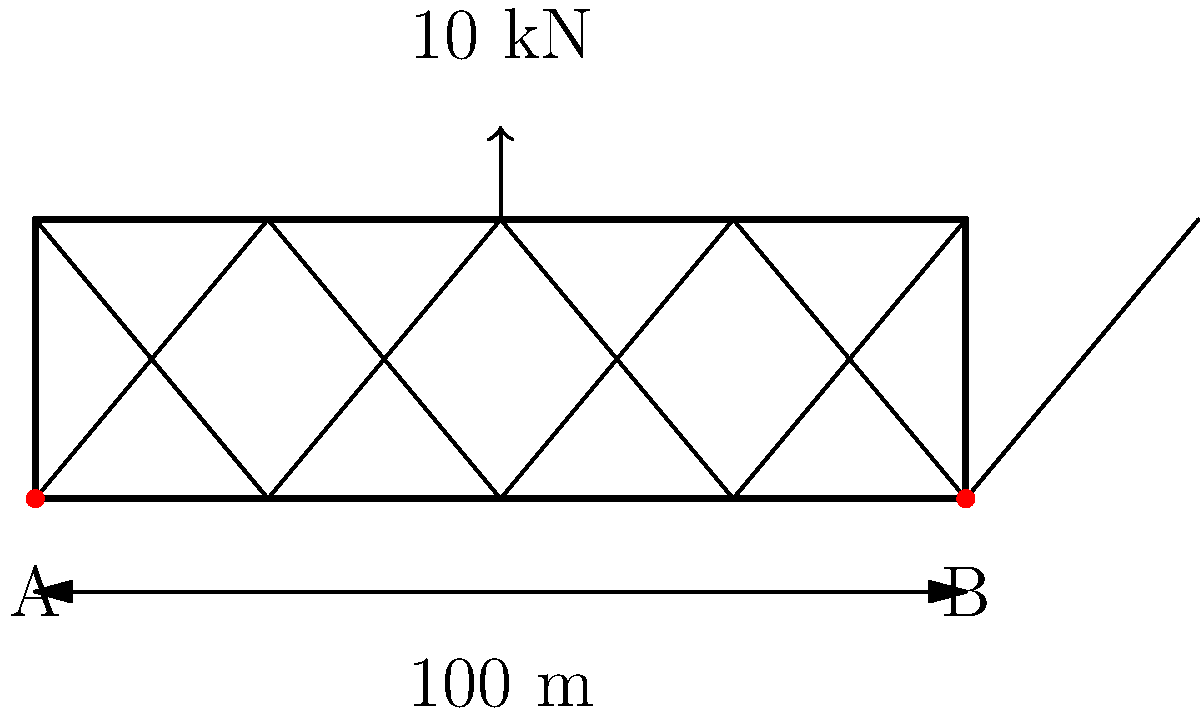In this absolutely groundbreaking and totally original truss bridge design (because who needs actual innovation when we can just recycle old ideas?), a 10 kN load is applied at the center of the top chord. Assuming this masterpiece of engineering is simply supported at A and B, what's the reaction force at support B? Don't strain yourself too much; it's not like understanding this will make you the next Banksy of bridge design. Alright, let's break this down for those who might be more interested in the structural integrity of their NFT collection than actual bridges:

1) First, we need to realize this is a simple statics problem. The bridge is in equilibrium, so the sum of all forces and moments must be zero.

2) Let's define our coordinate system:
   - Positive vertical forces point upward
   - Positive moments are counterclockwise

3) Let $R_A$ and $R_B$ be the reaction forces at supports A and B, respectively.

4) Sum of vertical forces must be zero:
   $$R_A + R_B - 10 \text{ kN} = 0$$

5) Sum of moments about point A must be zero:
   $$R_B \cdot 100 \text{ m} - 10 \text{ kN} \cdot 50 \text{ m} = 0$$

6) Solve for $R_B$:
   $$R_B = \frac{10 \text{ kN} \cdot 50 \text{ m}}{100 \text{ m}} = 5 \text{ kN}$$

7) If you're still following and haven't wandered off to mint a new NFT, you've now found the reaction force at B.
Answer: 5 kN 